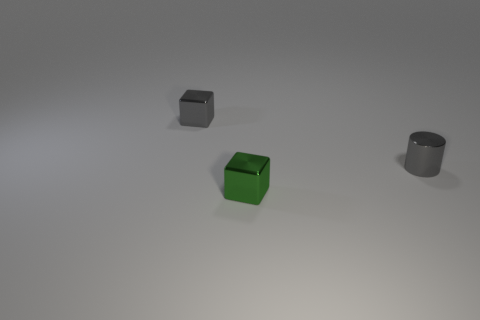How many red blocks have the same material as the green thing?
Provide a short and direct response. 0. What is the color of the cylinder that is the same material as the small green block?
Provide a short and direct response. Gray. What size is the gray metallic object to the left of the tiny gray metal object in front of the tiny block that is behind the metal cylinder?
Give a very brief answer. Small. Are there fewer gray cylinders than large green matte things?
Offer a terse response. No. There is another object that is the same shape as the small green shiny object; what is its color?
Give a very brief answer. Gray. There is a block left of the cube in front of the gray cube; is there a tiny gray shiny block on the left side of it?
Offer a terse response. No. Are there fewer gray cubes on the right side of the metal cylinder than small objects?
Make the answer very short. Yes. What is the color of the object on the left side of the small shiny block in front of the gray thing that is left of the tiny gray shiny cylinder?
Keep it short and to the point. Gray. What number of rubber things are small red spheres or tiny green cubes?
Make the answer very short. 0. Do the gray metallic cylinder and the green shiny thing have the same size?
Make the answer very short. Yes. 